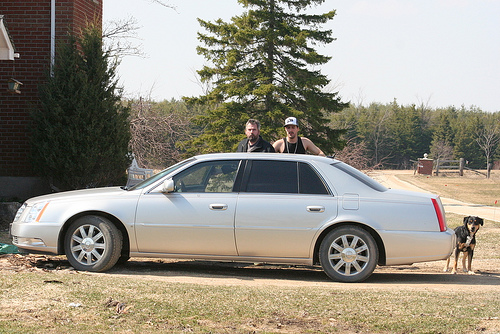<image>
Can you confirm if the dog is in the car? No. The dog is not contained within the car. These objects have a different spatial relationship. Is the car to the left of the dog? Yes. From this viewpoint, the car is positioned to the left side relative to the dog. 